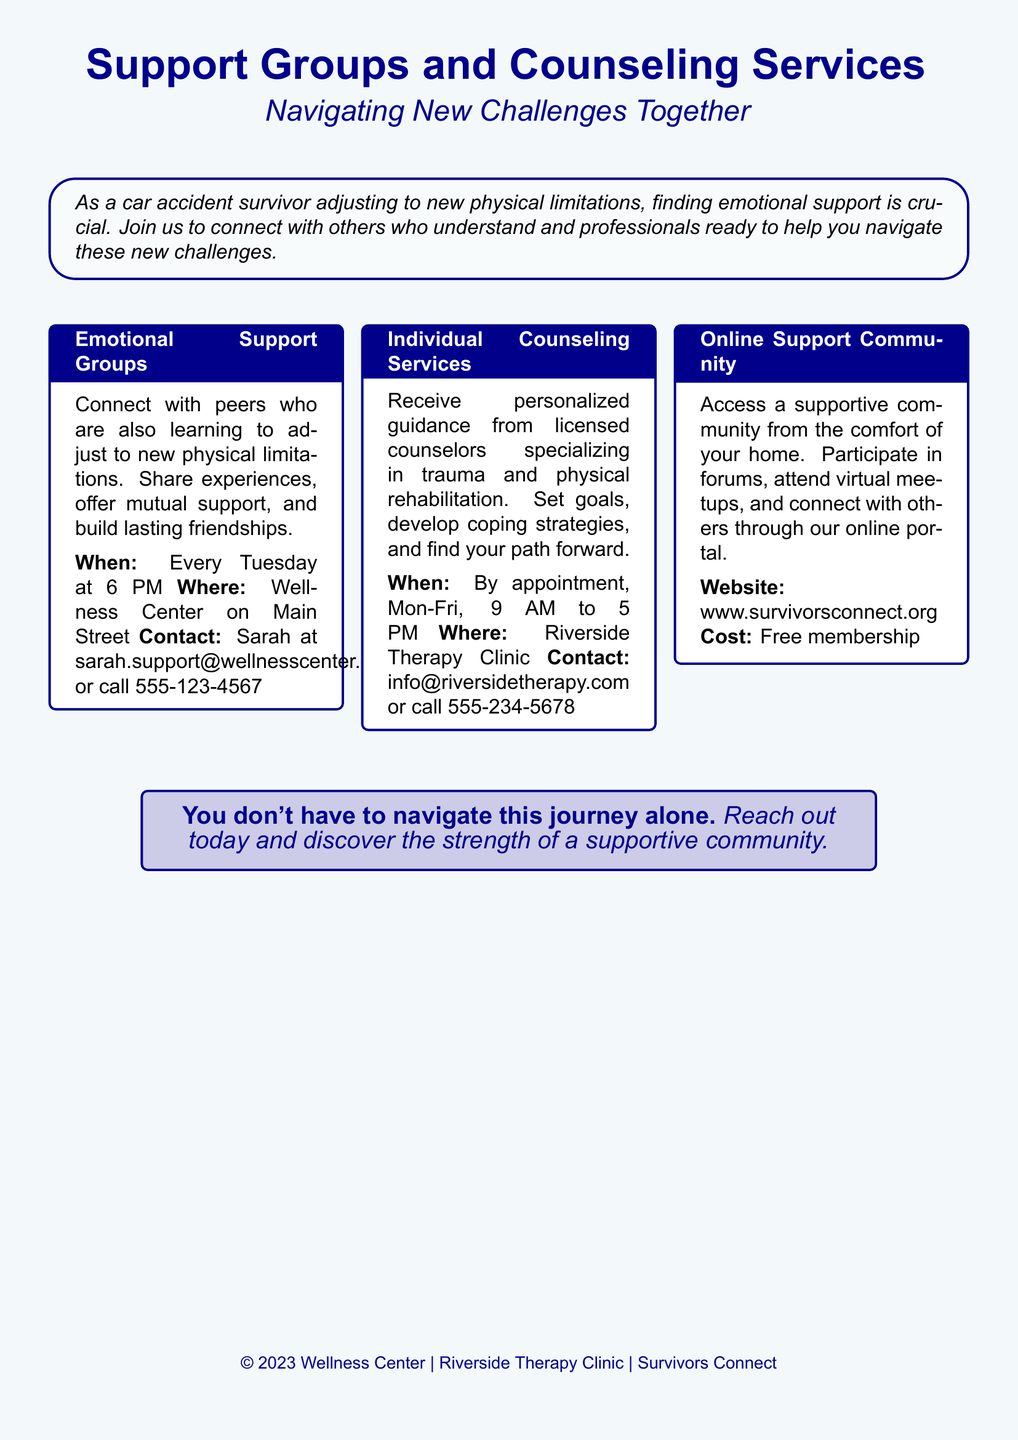What time do emotional support groups meet? The time for emotional support groups is specified in the document under the respective section, mentioning that they meet every Tuesday at 6 PM.
Answer: Every Tuesday at 6 PM Where is the emotional support group located? The document states the location of the emotional support groups, which is the Wellness Center on Main Street.
Answer: Wellness Center on Main Street Who do I contact for support groups? The document provides contact information for the support groups, specifically mentioning Sarah's email and phone number for inquiries.
Answer: Sarah at sarah.support@wellnesscenter.org or call 555-123-4567 What type of professionals provide individual counseling? The document details that licensed counselors, specializing in trauma and physical rehabilitation, provide the individual counseling services.
Answer: Licensed counselors How can I access the online support community? The document introduces the online support community and provides the website link for accessing it.
Answer: www.survivorsconnect.org What is the cost of membership in the online support community? The document specifies that the cost for joining the online support community is free membership.
Answer: Free membership When are individual counseling services available? The document lists the availability for individual counseling services, indicating the days and hours they are open for appointments.
Answer: By appointment, Mon-Fri, 9 AM to 5 PM What message does the advertisement convey about community? The advertisement emphasizes the strength of community support throughout the journey of recovery, highlighting that you don't have to navigate alone.
Answer: You don't have to navigate this journey alone What is the primary aim of the support provided? The document describes the main goal of the support services as helping car accident survivors navigate new challenges together through emotional support.
Answer: Navigating new challenges together 